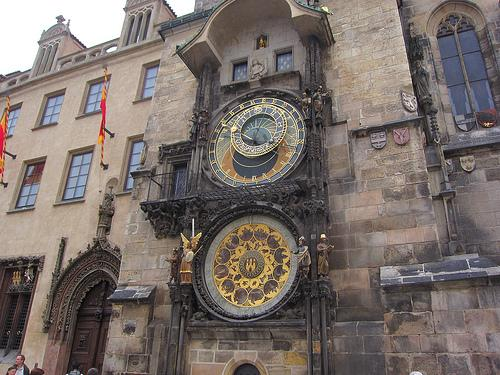What are some architectural details of the building in the image? The building has an astrological clock, a wooden door with an ornate archway, and a statue at its top. Provide a brief overview of the notable objects in the image. The image features an astrological clock, a brown building with closed windows, wooden doors, a statue, a red and yellow flag, and people outside the building. Describe the flags and their placement in the image. There are red and yellow flags hanging from the side of the building and a still red and yellow flag on the wall. Talk about the atmospheric conditions portrayed in the image. The sky is white, bright, sunny, and cloudless, indicating favorable weather conditions. Talk about the people and their actions outside the building. People are walking on the street near the building; a man wearing glasses and a blue shirt stands near the building. Give an account of the windows and their state in the photo. Most windows on the side of the building are closed with a cherub positioned between two of them. Identify the different elements of the astrological clock. The astrological clock is blue and gold with an astronomical artifact, and an angel is positioned next to it. Briefly describe the door and its features in the image. The door is a brown wooden one, featured under a carved ornate archway in a heavily decorated porch. Mention some key colors present in the image. Prominent colors in the image include blue, gold, brown, red, and yellow. Describe the building's exterior materials and colors. The building is made of brown stone blocks with gold ornate medallion ornamentation. 